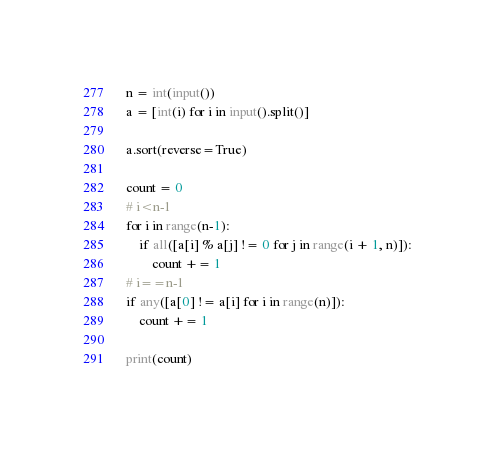<code> <loc_0><loc_0><loc_500><loc_500><_Python_>n = int(input())
a = [int(i) for i in input().split()]

a.sort(reverse=True)

count = 0
# i<n-1
for i in range(n-1):
    if all([a[i] % a[j] != 0 for j in range(i + 1, n)]):
        count += 1
# i==n-1
if any([a[0] != a[i] for i in range(n)]):
    count += 1
    
print(count)</code> 